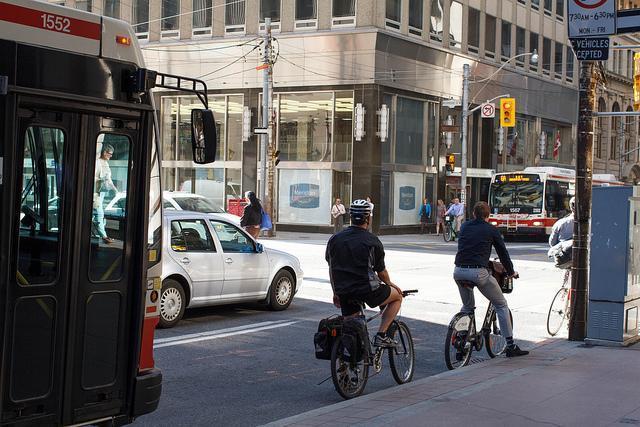How many modes of transportation are visible?
Give a very brief answer. 3. How many people can you see?
Give a very brief answer. 2. How many buses are in the photo?
Give a very brief answer. 2. How many bicycles are there?
Give a very brief answer. 2. How many cats are meowing on a bed?
Give a very brief answer. 0. 